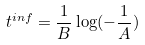<formula> <loc_0><loc_0><loc_500><loc_500>t ^ { i n f } = \frac { 1 } { B } \log ( - \frac { 1 } { A } )</formula> 